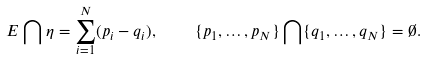Convert formula to latex. <formula><loc_0><loc_0><loc_500><loc_500>E \bigcap \eta = \sum _ { i = 1 } ^ { N } ( p _ { i } - q _ { i } ) , \quad \{ p _ { 1 } , \dots , p _ { N } \} \bigcap \{ q _ { 1 } , \dots , q _ { N } \} = \emptyset .</formula> 